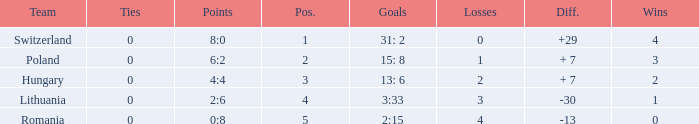Which team had fewer than 2 losses and a position number more than 1? Poland. 